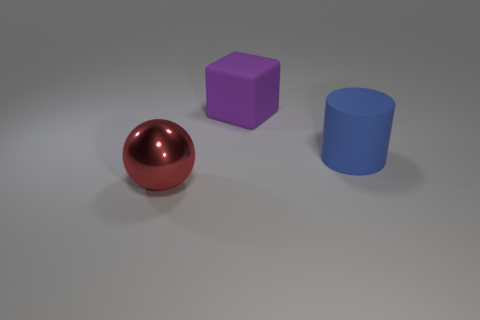Is the color of the large matte cylinder to the right of the purple matte thing the same as the big object to the left of the purple matte block?
Your answer should be compact. No. How many large things are in front of the big blue object and to the right of the big red thing?
Offer a terse response. 0. There is a object that is made of the same material as the large cylinder; what is its size?
Your answer should be very brief. Large. The red ball has what size?
Provide a short and direct response. Large. What is the material of the big purple block?
Give a very brief answer. Rubber. There is a metallic ball in front of the purple rubber object; does it have the same size as the big blue cylinder?
Provide a succinct answer. Yes. What number of things are either purple objects or large objects?
Offer a very short reply. 3. There is a object that is both to the left of the blue cylinder and right of the big red thing; how big is it?
Offer a very short reply. Large. What number of big purple rubber cubes are there?
Give a very brief answer. 1. How many blocks are either big blue matte objects or brown shiny objects?
Provide a succinct answer. 0. 